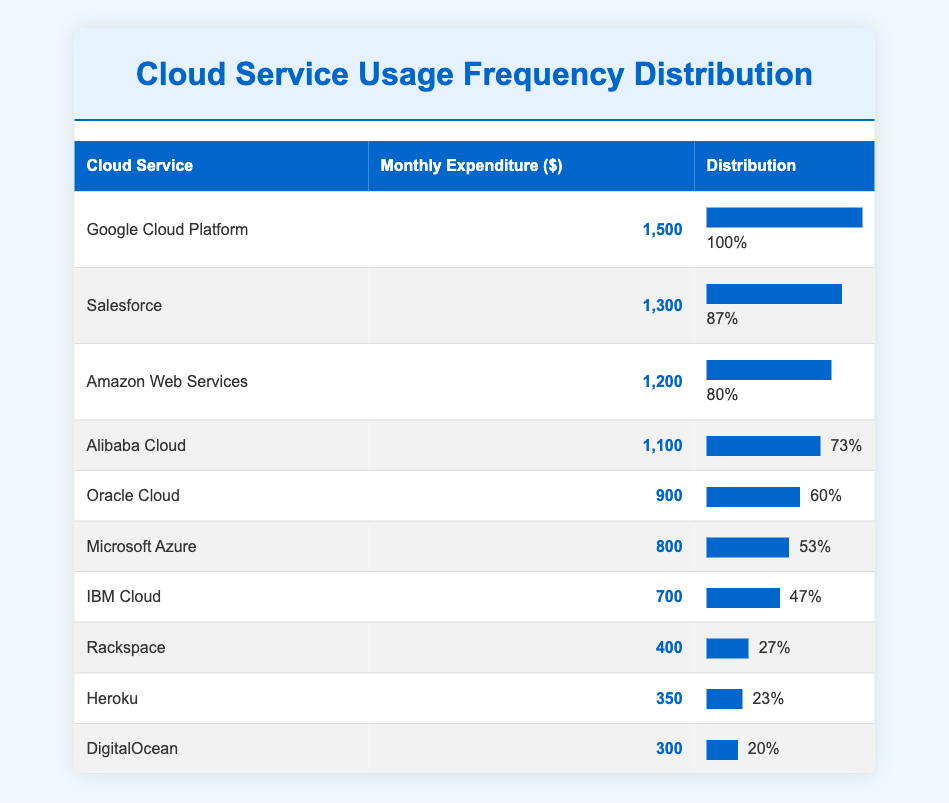What is the monthly expenditure for the Google Cloud Platform? The table shows that the monthly expenditure for the Google Cloud Platform is listed clearly in the corresponding row. It states $1,500 under the "Monthly Expenditure" column.
Answer: 1,500 Which cloud service has the lowest monthly expenditure? By reviewing the table, I see that DigitalOcean has the lowest monthly expenditure listed at $300. This is found by comparing all the expenditures in the table.
Answer: DigitalOcean How many services have a monthly expenditure of over $1,000? To determine this, I count the entries where the "Monthly Expenditure" is over $1,000. The services that meet this criteria are Google Cloud Platform ($1,500), Salesforce ($1,300), Amazon Web Services ($1,200), and Alibaba Cloud ($1,100), totaling 4 services.
Answer: 4 What is the total monthly expenditure for all listed cloud services? First, I sum the expenditures for all services: 1,500 + 1,300 + 1,200 + 1,100 + 900 + 800 + 700 + 400 + 350 + 300. This results in a total of $8,650.
Answer: 8,650 Is Salesforce's monthly expenditure greater than Microsoft Azure's monthly expenditure? By examining the table, Salesforce has a monthly expenditure of $1,300 and Microsoft Azure has $800. Since $1,300 is indeed greater than $800, the statement is true.
Answer: Yes Which cloud service has a monthly expenditure closest to the average of all expenditures? First, I must calculate the average. The total expenditure is $8,650, and there are 10 services. The average expenditure is 8,650 / 10 = $865. The services with expenditures closest to $865 are Oracle Cloud ($900) and Microsoft Azure ($800). The closest value is Microsoft's expenditure as it is only $65 less than the average while Oracle is $35 more.
Answer: Microsoft Azure What percentage of services have a monthly expenditure below $500? Out of the 10 services, only DigitalOcean ($300) and Heroku ($350) fall below $500. This means 2 out of 10 services, thus the percentage is (2/10)*100 = 20%.
Answer: 20% 